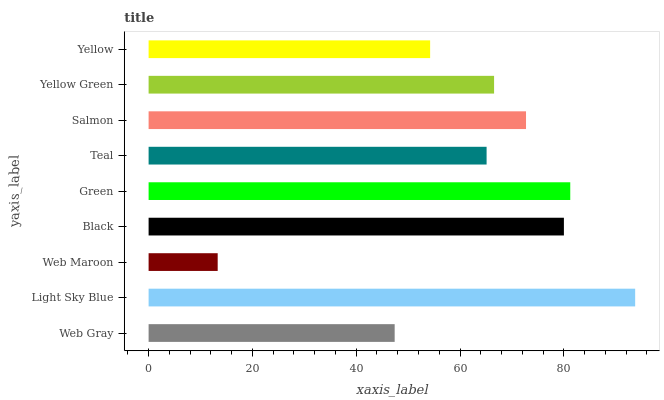Is Web Maroon the minimum?
Answer yes or no. Yes. Is Light Sky Blue the maximum?
Answer yes or no. Yes. Is Light Sky Blue the minimum?
Answer yes or no. No. Is Web Maroon the maximum?
Answer yes or no. No. Is Light Sky Blue greater than Web Maroon?
Answer yes or no. Yes. Is Web Maroon less than Light Sky Blue?
Answer yes or no. Yes. Is Web Maroon greater than Light Sky Blue?
Answer yes or no. No. Is Light Sky Blue less than Web Maroon?
Answer yes or no. No. Is Yellow Green the high median?
Answer yes or no. Yes. Is Yellow Green the low median?
Answer yes or no. Yes. Is Black the high median?
Answer yes or no. No. Is Yellow the low median?
Answer yes or no. No. 